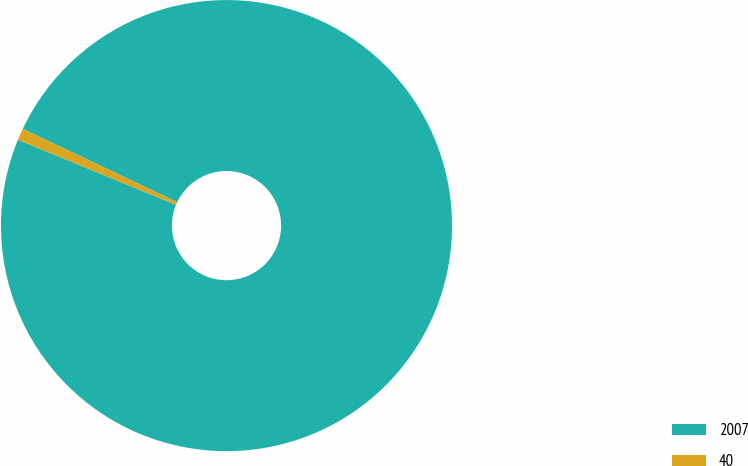Convert chart. <chart><loc_0><loc_0><loc_500><loc_500><pie_chart><fcel>2007<fcel>40<nl><fcel>99.16%<fcel>0.84%<nl></chart> 